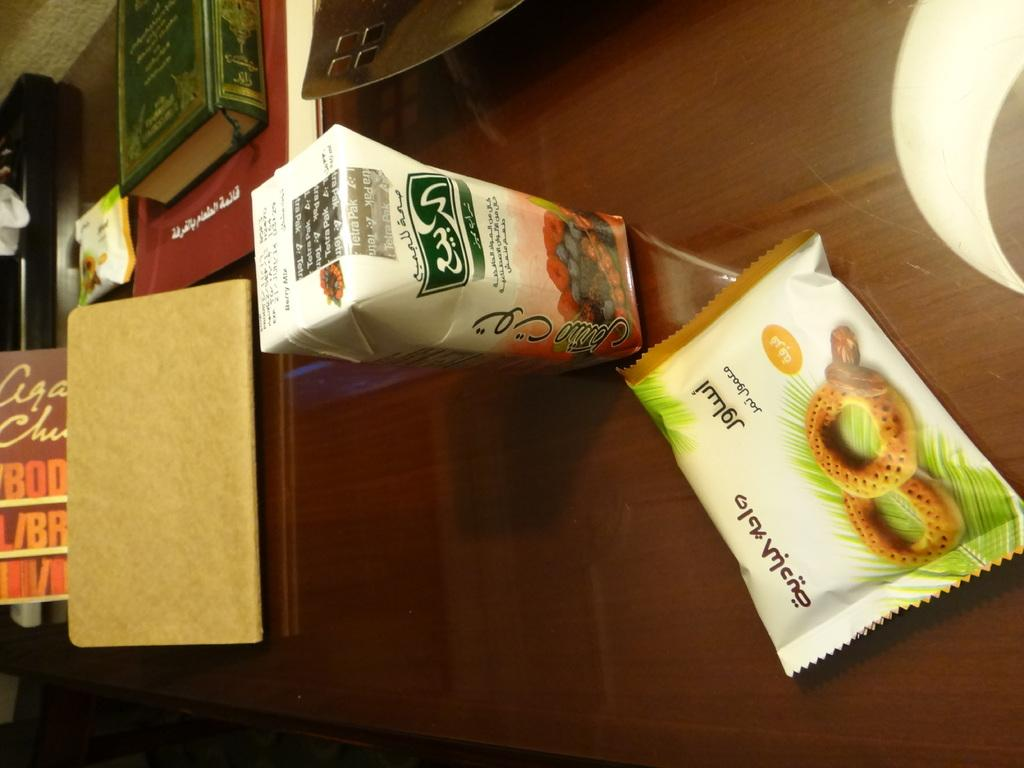What objects are on the table in the image? There are books and packets on the table. Can you describe any other items on the table? Yes, there are other things on the table. What might the packets contain? It is not clear from the image what the packets contain. Can you see any planes taking off at the airport in the image? There is no airport or plane visible in the image; it only shows objects on a table. 